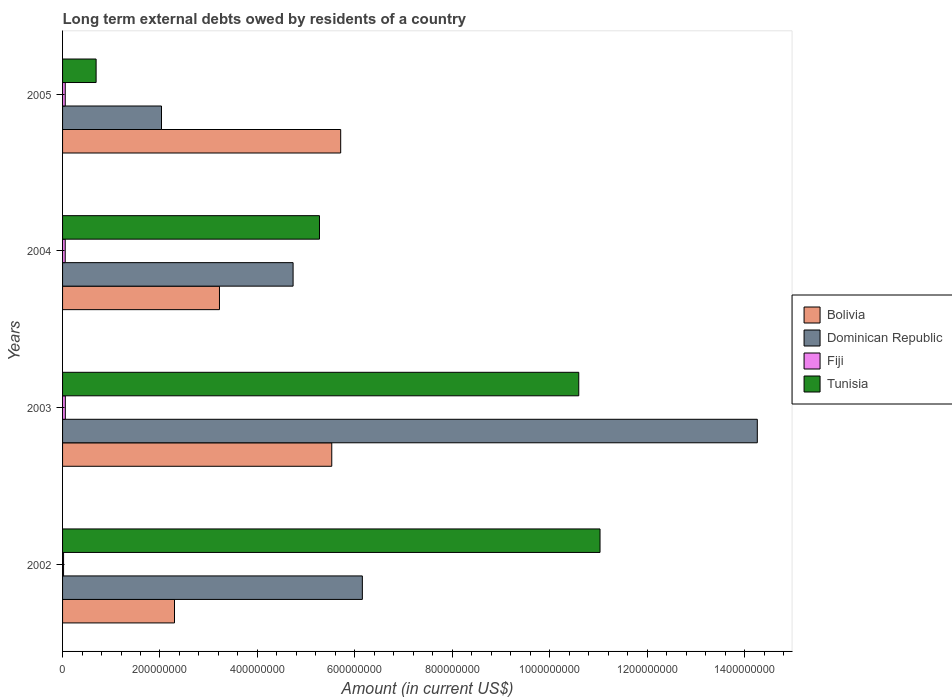How many different coloured bars are there?
Your response must be concise. 4. Are the number of bars on each tick of the Y-axis equal?
Ensure brevity in your answer.  Yes. How many bars are there on the 1st tick from the bottom?
Your answer should be compact. 4. What is the label of the 4th group of bars from the top?
Offer a very short reply. 2002. In how many cases, is the number of bars for a given year not equal to the number of legend labels?
Offer a very short reply. 0. What is the amount of long-term external debts owed by residents in Tunisia in 2005?
Your response must be concise. 6.89e+07. Across all years, what is the maximum amount of long-term external debts owed by residents in Bolivia?
Your answer should be compact. 5.71e+08. Across all years, what is the minimum amount of long-term external debts owed by residents in Tunisia?
Your response must be concise. 6.89e+07. In which year was the amount of long-term external debts owed by residents in Bolivia maximum?
Provide a succinct answer. 2005. What is the total amount of long-term external debts owed by residents in Fiji in the graph?
Give a very brief answer. 1.87e+07. What is the difference between the amount of long-term external debts owed by residents in Bolivia in 2002 and that in 2003?
Provide a short and direct response. -3.23e+08. What is the difference between the amount of long-term external debts owed by residents in Bolivia in 2003 and the amount of long-term external debts owed by residents in Dominican Republic in 2002?
Offer a terse response. -6.28e+07. What is the average amount of long-term external debts owed by residents in Bolivia per year?
Your answer should be very brief. 4.19e+08. In the year 2003, what is the difference between the amount of long-term external debts owed by residents in Tunisia and amount of long-term external debts owed by residents in Bolivia?
Your answer should be compact. 5.07e+08. What is the ratio of the amount of long-term external debts owed by residents in Dominican Republic in 2003 to that in 2005?
Your answer should be compact. 7.02. Is the amount of long-term external debts owed by residents in Dominican Republic in 2003 less than that in 2004?
Provide a succinct answer. No. Is the difference between the amount of long-term external debts owed by residents in Tunisia in 2004 and 2005 greater than the difference between the amount of long-term external debts owed by residents in Bolivia in 2004 and 2005?
Your answer should be very brief. Yes. What is the difference between the highest and the second highest amount of long-term external debts owed by residents in Fiji?
Keep it short and to the point. 1.32e+05. What is the difference between the highest and the lowest amount of long-term external debts owed by residents in Bolivia?
Give a very brief answer. 3.41e+08. In how many years, is the amount of long-term external debts owed by residents in Fiji greater than the average amount of long-term external debts owed by residents in Fiji taken over all years?
Your answer should be compact. 3. What does the 2nd bar from the bottom in 2005 represents?
Your answer should be very brief. Dominican Republic. Is it the case that in every year, the sum of the amount of long-term external debts owed by residents in Dominican Republic and amount of long-term external debts owed by residents in Fiji is greater than the amount of long-term external debts owed by residents in Bolivia?
Your answer should be very brief. No. Are all the bars in the graph horizontal?
Make the answer very short. Yes. How many years are there in the graph?
Offer a terse response. 4. What is the difference between two consecutive major ticks on the X-axis?
Provide a succinct answer. 2.00e+08. Does the graph contain any zero values?
Provide a short and direct response. No. How many legend labels are there?
Make the answer very short. 4. What is the title of the graph?
Provide a succinct answer. Long term external debts owed by residents of a country. What is the label or title of the Y-axis?
Ensure brevity in your answer.  Years. What is the Amount (in current US$) in Bolivia in 2002?
Provide a short and direct response. 2.30e+08. What is the Amount (in current US$) of Dominican Republic in 2002?
Make the answer very short. 6.15e+08. What is the Amount (in current US$) of Fiji in 2002?
Offer a very short reply. 2.05e+06. What is the Amount (in current US$) of Tunisia in 2002?
Provide a short and direct response. 1.10e+09. What is the Amount (in current US$) in Bolivia in 2003?
Provide a succinct answer. 5.53e+08. What is the Amount (in current US$) of Dominican Republic in 2003?
Your answer should be very brief. 1.43e+09. What is the Amount (in current US$) in Fiji in 2003?
Give a very brief answer. 5.66e+06. What is the Amount (in current US$) in Tunisia in 2003?
Offer a very short reply. 1.06e+09. What is the Amount (in current US$) in Bolivia in 2004?
Offer a very short reply. 3.22e+08. What is the Amount (in current US$) in Dominican Republic in 2004?
Ensure brevity in your answer.  4.73e+08. What is the Amount (in current US$) of Fiji in 2004?
Provide a short and direct response. 5.46e+06. What is the Amount (in current US$) in Tunisia in 2004?
Give a very brief answer. 5.27e+08. What is the Amount (in current US$) of Bolivia in 2005?
Provide a short and direct response. 5.71e+08. What is the Amount (in current US$) of Dominican Republic in 2005?
Make the answer very short. 2.03e+08. What is the Amount (in current US$) in Fiji in 2005?
Provide a succinct answer. 5.53e+06. What is the Amount (in current US$) in Tunisia in 2005?
Your answer should be compact. 6.89e+07. Across all years, what is the maximum Amount (in current US$) of Bolivia?
Provide a short and direct response. 5.71e+08. Across all years, what is the maximum Amount (in current US$) of Dominican Republic?
Make the answer very short. 1.43e+09. Across all years, what is the maximum Amount (in current US$) in Fiji?
Keep it short and to the point. 5.66e+06. Across all years, what is the maximum Amount (in current US$) of Tunisia?
Offer a terse response. 1.10e+09. Across all years, what is the minimum Amount (in current US$) in Bolivia?
Make the answer very short. 2.30e+08. Across all years, what is the minimum Amount (in current US$) of Dominican Republic?
Offer a very short reply. 2.03e+08. Across all years, what is the minimum Amount (in current US$) in Fiji?
Offer a terse response. 2.05e+06. Across all years, what is the minimum Amount (in current US$) in Tunisia?
Give a very brief answer. 6.89e+07. What is the total Amount (in current US$) of Bolivia in the graph?
Provide a succinct answer. 1.68e+09. What is the total Amount (in current US$) of Dominican Republic in the graph?
Your response must be concise. 2.72e+09. What is the total Amount (in current US$) in Fiji in the graph?
Provide a short and direct response. 1.87e+07. What is the total Amount (in current US$) of Tunisia in the graph?
Your response must be concise. 2.76e+09. What is the difference between the Amount (in current US$) in Bolivia in 2002 and that in 2003?
Give a very brief answer. -3.23e+08. What is the difference between the Amount (in current US$) of Dominican Republic in 2002 and that in 2003?
Ensure brevity in your answer.  -8.11e+08. What is the difference between the Amount (in current US$) in Fiji in 2002 and that in 2003?
Make the answer very short. -3.61e+06. What is the difference between the Amount (in current US$) of Tunisia in 2002 and that in 2003?
Your answer should be compact. 4.36e+07. What is the difference between the Amount (in current US$) of Bolivia in 2002 and that in 2004?
Ensure brevity in your answer.  -9.23e+07. What is the difference between the Amount (in current US$) of Dominican Republic in 2002 and that in 2004?
Keep it short and to the point. 1.42e+08. What is the difference between the Amount (in current US$) in Fiji in 2002 and that in 2004?
Provide a short and direct response. -3.41e+06. What is the difference between the Amount (in current US$) of Tunisia in 2002 and that in 2004?
Provide a succinct answer. 5.76e+08. What is the difference between the Amount (in current US$) in Bolivia in 2002 and that in 2005?
Ensure brevity in your answer.  -3.41e+08. What is the difference between the Amount (in current US$) in Dominican Republic in 2002 and that in 2005?
Your response must be concise. 4.12e+08. What is the difference between the Amount (in current US$) of Fiji in 2002 and that in 2005?
Keep it short and to the point. -3.48e+06. What is the difference between the Amount (in current US$) in Tunisia in 2002 and that in 2005?
Ensure brevity in your answer.  1.03e+09. What is the difference between the Amount (in current US$) in Bolivia in 2003 and that in 2004?
Provide a short and direct response. 2.31e+08. What is the difference between the Amount (in current US$) of Dominican Republic in 2003 and that in 2004?
Your answer should be very brief. 9.53e+08. What is the difference between the Amount (in current US$) of Fiji in 2003 and that in 2004?
Ensure brevity in your answer.  2.00e+05. What is the difference between the Amount (in current US$) in Tunisia in 2003 and that in 2004?
Make the answer very short. 5.32e+08. What is the difference between the Amount (in current US$) in Bolivia in 2003 and that in 2005?
Keep it short and to the point. -1.83e+07. What is the difference between the Amount (in current US$) of Dominican Republic in 2003 and that in 2005?
Give a very brief answer. 1.22e+09. What is the difference between the Amount (in current US$) in Fiji in 2003 and that in 2005?
Offer a terse response. 1.32e+05. What is the difference between the Amount (in current US$) in Tunisia in 2003 and that in 2005?
Provide a short and direct response. 9.91e+08. What is the difference between the Amount (in current US$) in Bolivia in 2004 and that in 2005?
Your answer should be very brief. -2.49e+08. What is the difference between the Amount (in current US$) in Dominican Republic in 2004 and that in 2005?
Your response must be concise. 2.70e+08. What is the difference between the Amount (in current US$) in Fiji in 2004 and that in 2005?
Your response must be concise. -6.80e+04. What is the difference between the Amount (in current US$) of Tunisia in 2004 and that in 2005?
Ensure brevity in your answer.  4.59e+08. What is the difference between the Amount (in current US$) of Bolivia in 2002 and the Amount (in current US$) of Dominican Republic in 2003?
Ensure brevity in your answer.  -1.20e+09. What is the difference between the Amount (in current US$) of Bolivia in 2002 and the Amount (in current US$) of Fiji in 2003?
Make the answer very short. 2.24e+08. What is the difference between the Amount (in current US$) of Bolivia in 2002 and the Amount (in current US$) of Tunisia in 2003?
Ensure brevity in your answer.  -8.30e+08. What is the difference between the Amount (in current US$) in Dominican Republic in 2002 and the Amount (in current US$) in Fiji in 2003?
Your response must be concise. 6.10e+08. What is the difference between the Amount (in current US$) in Dominican Republic in 2002 and the Amount (in current US$) in Tunisia in 2003?
Keep it short and to the point. -4.44e+08. What is the difference between the Amount (in current US$) of Fiji in 2002 and the Amount (in current US$) of Tunisia in 2003?
Make the answer very short. -1.06e+09. What is the difference between the Amount (in current US$) of Bolivia in 2002 and the Amount (in current US$) of Dominican Republic in 2004?
Your answer should be compact. -2.43e+08. What is the difference between the Amount (in current US$) of Bolivia in 2002 and the Amount (in current US$) of Fiji in 2004?
Your response must be concise. 2.24e+08. What is the difference between the Amount (in current US$) in Bolivia in 2002 and the Amount (in current US$) in Tunisia in 2004?
Provide a succinct answer. -2.98e+08. What is the difference between the Amount (in current US$) in Dominican Republic in 2002 and the Amount (in current US$) in Fiji in 2004?
Offer a very short reply. 6.10e+08. What is the difference between the Amount (in current US$) in Dominican Republic in 2002 and the Amount (in current US$) in Tunisia in 2004?
Offer a very short reply. 8.80e+07. What is the difference between the Amount (in current US$) in Fiji in 2002 and the Amount (in current US$) in Tunisia in 2004?
Your answer should be compact. -5.25e+08. What is the difference between the Amount (in current US$) of Bolivia in 2002 and the Amount (in current US$) of Dominican Republic in 2005?
Offer a very short reply. 2.67e+07. What is the difference between the Amount (in current US$) in Bolivia in 2002 and the Amount (in current US$) in Fiji in 2005?
Ensure brevity in your answer.  2.24e+08. What is the difference between the Amount (in current US$) in Bolivia in 2002 and the Amount (in current US$) in Tunisia in 2005?
Give a very brief answer. 1.61e+08. What is the difference between the Amount (in current US$) of Dominican Republic in 2002 and the Amount (in current US$) of Fiji in 2005?
Your answer should be very brief. 6.10e+08. What is the difference between the Amount (in current US$) in Dominican Republic in 2002 and the Amount (in current US$) in Tunisia in 2005?
Keep it short and to the point. 5.47e+08. What is the difference between the Amount (in current US$) of Fiji in 2002 and the Amount (in current US$) of Tunisia in 2005?
Offer a terse response. -6.68e+07. What is the difference between the Amount (in current US$) in Bolivia in 2003 and the Amount (in current US$) in Dominican Republic in 2004?
Give a very brief answer. 7.94e+07. What is the difference between the Amount (in current US$) of Bolivia in 2003 and the Amount (in current US$) of Fiji in 2004?
Your answer should be very brief. 5.47e+08. What is the difference between the Amount (in current US$) in Bolivia in 2003 and the Amount (in current US$) in Tunisia in 2004?
Your answer should be very brief. 2.52e+07. What is the difference between the Amount (in current US$) in Dominican Republic in 2003 and the Amount (in current US$) in Fiji in 2004?
Keep it short and to the point. 1.42e+09. What is the difference between the Amount (in current US$) in Dominican Republic in 2003 and the Amount (in current US$) in Tunisia in 2004?
Offer a very short reply. 8.99e+08. What is the difference between the Amount (in current US$) of Fiji in 2003 and the Amount (in current US$) of Tunisia in 2004?
Give a very brief answer. -5.22e+08. What is the difference between the Amount (in current US$) of Bolivia in 2003 and the Amount (in current US$) of Dominican Republic in 2005?
Keep it short and to the point. 3.50e+08. What is the difference between the Amount (in current US$) in Bolivia in 2003 and the Amount (in current US$) in Fiji in 2005?
Your answer should be compact. 5.47e+08. What is the difference between the Amount (in current US$) of Bolivia in 2003 and the Amount (in current US$) of Tunisia in 2005?
Offer a terse response. 4.84e+08. What is the difference between the Amount (in current US$) of Dominican Republic in 2003 and the Amount (in current US$) of Fiji in 2005?
Keep it short and to the point. 1.42e+09. What is the difference between the Amount (in current US$) in Dominican Republic in 2003 and the Amount (in current US$) in Tunisia in 2005?
Offer a terse response. 1.36e+09. What is the difference between the Amount (in current US$) in Fiji in 2003 and the Amount (in current US$) in Tunisia in 2005?
Ensure brevity in your answer.  -6.32e+07. What is the difference between the Amount (in current US$) in Bolivia in 2004 and the Amount (in current US$) in Dominican Republic in 2005?
Offer a very short reply. 1.19e+08. What is the difference between the Amount (in current US$) of Bolivia in 2004 and the Amount (in current US$) of Fiji in 2005?
Offer a very short reply. 3.17e+08. What is the difference between the Amount (in current US$) in Bolivia in 2004 and the Amount (in current US$) in Tunisia in 2005?
Offer a very short reply. 2.53e+08. What is the difference between the Amount (in current US$) of Dominican Republic in 2004 and the Amount (in current US$) of Fiji in 2005?
Make the answer very short. 4.68e+08. What is the difference between the Amount (in current US$) of Dominican Republic in 2004 and the Amount (in current US$) of Tunisia in 2005?
Ensure brevity in your answer.  4.04e+08. What is the difference between the Amount (in current US$) in Fiji in 2004 and the Amount (in current US$) in Tunisia in 2005?
Keep it short and to the point. -6.34e+07. What is the average Amount (in current US$) of Bolivia per year?
Keep it short and to the point. 4.19e+08. What is the average Amount (in current US$) in Dominican Republic per year?
Offer a very short reply. 6.80e+08. What is the average Amount (in current US$) of Fiji per year?
Give a very brief answer. 4.67e+06. What is the average Amount (in current US$) in Tunisia per year?
Your answer should be compact. 6.90e+08. In the year 2002, what is the difference between the Amount (in current US$) of Bolivia and Amount (in current US$) of Dominican Republic?
Make the answer very short. -3.86e+08. In the year 2002, what is the difference between the Amount (in current US$) in Bolivia and Amount (in current US$) in Fiji?
Provide a short and direct response. 2.28e+08. In the year 2002, what is the difference between the Amount (in current US$) of Bolivia and Amount (in current US$) of Tunisia?
Provide a succinct answer. -8.74e+08. In the year 2002, what is the difference between the Amount (in current US$) of Dominican Republic and Amount (in current US$) of Fiji?
Ensure brevity in your answer.  6.13e+08. In the year 2002, what is the difference between the Amount (in current US$) of Dominican Republic and Amount (in current US$) of Tunisia?
Offer a terse response. -4.88e+08. In the year 2002, what is the difference between the Amount (in current US$) in Fiji and Amount (in current US$) in Tunisia?
Offer a terse response. -1.10e+09. In the year 2003, what is the difference between the Amount (in current US$) in Bolivia and Amount (in current US$) in Dominican Republic?
Offer a terse response. -8.74e+08. In the year 2003, what is the difference between the Amount (in current US$) of Bolivia and Amount (in current US$) of Fiji?
Make the answer very short. 5.47e+08. In the year 2003, what is the difference between the Amount (in current US$) in Bolivia and Amount (in current US$) in Tunisia?
Your answer should be compact. -5.07e+08. In the year 2003, what is the difference between the Amount (in current US$) in Dominican Republic and Amount (in current US$) in Fiji?
Make the answer very short. 1.42e+09. In the year 2003, what is the difference between the Amount (in current US$) in Dominican Republic and Amount (in current US$) in Tunisia?
Give a very brief answer. 3.67e+08. In the year 2003, what is the difference between the Amount (in current US$) in Fiji and Amount (in current US$) in Tunisia?
Make the answer very short. -1.05e+09. In the year 2004, what is the difference between the Amount (in current US$) of Bolivia and Amount (in current US$) of Dominican Republic?
Your answer should be compact. -1.51e+08. In the year 2004, what is the difference between the Amount (in current US$) in Bolivia and Amount (in current US$) in Fiji?
Provide a succinct answer. 3.17e+08. In the year 2004, what is the difference between the Amount (in current US$) of Bolivia and Amount (in current US$) of Tunisia?
Make the answer very short. -2.05e+08. In the year 2004, what is the difference between the Amount (in current US$) in Dominican Republic and Amount (in current US$) in Fiji?
Give a very brief answer. 4.68e+08. In the year 2004, what is the difference between the Amount (in current US$) of Dominican Republic and Amount (in current US$) of Tunisia?
Make the answer very short. -5.42e+07. In the year 2004, what is the difference between the Amount (in current US$) in Fiji and Amount (in current US$) in Tunisia?
Ensure brevity in your answer.  -5.22e+08. In the year 2005, what is the difference between the Amount (in current US$) in Bolivia and Amount (in current US$) in Dominican Republic?
Offer a terse response. 3.68e+08. In the year 2005, what is the difference between the Amount (in current US$) in Bolivia and Amount (in current US$) in Fiji?
Offer a very short reply. 5.65e+08. In the year 2005, what is the difference between the Amount (in current US$) in Bolivia and Amount (in current US$) in Tunisia?
Make the answer very short. 5.02e+08. In the year 2005, what is the difference between the Amount (in current US$) of Dominican Republic and Amount (in current US$) of Fiji?
Offer a terse response. 1.98e+08. In the year 2005, what is the difference between the Amount (in current US$) of Dominican Republic and Amount (in current US$) of Tunisia?
Offer a terse response. 1.34e+08. In the year 2005, what is the difference between the Amount (in current US$) of Fiji and Amount (in current US$) of Tunisia?
Your response must be concise. -6.33e+07. What is the ratio of the Amount (in current US$) of Bolivia in 2002 to that in 2003?
Your response must be concise. 0.42. What is the ratio of the Amount (in current US$) of Dominican Republic in 2002 to that in 2003?
Make the answer very short. 0.43. What is the ratio of the Amount (in current US$) in Fiji in 2002 to that in 2003?
Make the answer very short. 0.36. What is the ratio of the Amount (in current US$) in Tunisia in 2002 to that in 2003?
Provide a succinct answer. 1.04. What is the ratio of the Amount (in current US$) of Bolivia in 2002 to that in 2004?
Provide a short and direct response. 0.71. What is the ratio of the Amount (in current US$) in Dominican Republic in 2002 to that in 2004?
Provide a short and direct response. 1.3. What is the ratio of the Amount (in current US$) in Fiji in 2002 to that in 2004?
Your answer should be compact. 0.38. What is the ratio of the Amount (in current US$) in Tunisia in 2002 to that in 2004?
Give a very brief answer. 2.09. What is the ratio of the Amount (in current US$) of Bolivia in 2002 to that in 2005?
Keep it short and to the point. 0.4. What is the ratio of the Amount (in current US$) of Dominican Republic in 2002 to that in 2005?
Keep it short and to the point. 3.03. What is the ratio of the Amount (in current US$) of Fiji in 2002 to that in 2005?
Provide a short and direct response. 0.37. What is the ratio of the Amount (in current US$) in Tunisia in 2002 to that in 2005?
Ensure brevity in your answer.  16.02. What is the ratio of the Amount (in current US$) of Bolivia in 2003 to that in 2004?
Your response must be concise. 1.72. What is the ratio of the Amount (in current US$) in Dominican Republic in 2003 to that in 2004?
Keep it short and to the point. 3.01. What is the ratio of the Amount (in current US$) in Fiji in 2003 to that in 2004?
Provide a succinct answer. 1.04. What is the ratio of the Amount (in current US$) in Tunisia in 2003 to that in 2004?
Your response must be concise. 2.01. What is the ratio of the Amount (in current US$) in Bolivia in 2003 to that in 2005?
Provide a succinct answer. 0.97. What is the ratio of the Amount (in current US$) of Dominican Republic in 2003 to that in 2005?
Provide a succinct answer. 7.02. What is the ratio of the Amount (in current US$) of Fiji in 2003 to that in 2005?
Your response must be concise. 1.02. What is the ratio of the Amount (in current US$) of Tunisia in 2003 to that in 2005?
Provide a succinct answer. 15.39. What is the ratio of the Amount (in current US$) of Bolivia in 2004 to that in 2005?
Offer a very short reply. 0.56. What is the ratio of the Amount (in current US$) of Dominican Republic in 2004 to that in 2005?
Offer a terse response. 2.33. What is the ratio of the Amount (in current US$) in Tunisia in 2004 to that in 2005?
Provide a short and direct response. 7.66. What is the difference between the highest and the second highest Amount (in current US$) in Bolivia?
Your answer should be very brief. 1.83e+07. What is the difference between the highest and the second highest Amount (in current US$) in Dominican Republic?
Your answer should be compact. 8.11e+08. What is the difference between the highest and the second highest Amount (in current US$) of Fiji?
Your response must be concise. 1.32e+05. What is the difference between the highest and the second highest Amount (in current US$) in Tunisia?
Your answer should be compact. 4.36e+07. What is the difference between the highest and the lowest Amount (in current US$) of Bolivia?
Provide a short and direct response. 3.41e+08. What is the difference between the highest and the lowest Amount (in current US$) in Dominican Republic?
Your answer should be very brief. 1.22e+09. What is the difference between the highest and the lowest Amount (in current US$) of Fiji?
Your answer should be very brief. 3.61e+06. What is the difference between the highest and the lowest Amount (in current US$) in Tunisia?
Keep it short and to the point. 1.03e+09. 